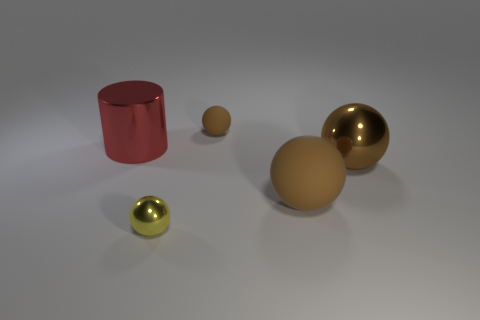Subtract all big shiny balls. How many balls are left? 3 Subtract all yellow balls. How many balls are left? 3 Subtract all cyan cylinders. How many brown spheres are left? 3 Add 1 tiny yellow cylinders. How many objects exist? 6 Subtract all cylinders. How many objects are left? 4 Add 1 red metallic cylinders. How many red metallic cylinders are left? 2 Add 4 balls. How many balls exist? 8 Subtract 0 blue balls. How many objects are left? 5 Subtract all cyan cylinders. Subtract all yellow blocks. How many cylinders are left? 1 Subtract all big brown rubber things. Subtract all brown metal spheres. How many objects are left? 3 